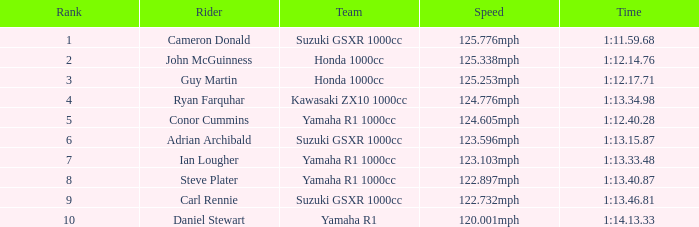Write the full table. {'header': ['Rank', 'Rider', 'Team', 'Speed', 'Time'], 'rows': [['1', 'Cameron Donald', 'Suzuki GSXR 1000cc', '125.776mph', '1:11.59.68'], ['2', 'John McGuinness', 'Honda 1000cc', '125.338mph', '1:12.14.76'], ['3', 'Guy Martin', 'Honda 1000cc', '125.253mph', '1:12.17.71'], ['4', 'Ryan Farquhar', 'Kawasaki ZX10 1000cc', '124.776mph', '1:13.34.98'], ['5', 'Conor Cummins', 'Yamaha R1 1000cc', '124.605mph', '1:12.40.28'], ['6', 'Adrian Archibald', 'Suzuki GSXR 1000cc', '123.596mph', '1:13.15.87'], ['7', 'Ian Lougher', 'Yamaha R1 1000cc', '123.103mph', '1:13.33.48'], ['8', 'Steve Plater', 'Yamaha R1 1000cc', '122.897mph', '1:13.40.87'], ['9', 'Carl Rennie', 'Suzuki GSXR 1000cc', '122.732mph', '1:13.46.81'], ['10', 'Daniel Stewart', 'Yamaha R1', '120.001mph', '1:14.13.33']]} 4 5.0. 